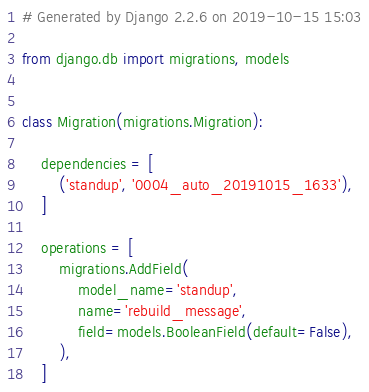Convert code to text. <code><loc_0><loc_0><loc_500><loc_500><_Python_># Generated by Django 2.2.6 on 2019-10-15 15:03

from django.db import migrations, models


class Migration(migrations.Migration):

    dependencies = [
        ('standup', '0004_auto_20191015_1633'),
    ]

    operations = [
        migrations.AddField(
            model_name='standup',
            name='rebuild_message',
            field=models.BooleanField(default=False),
        ),
    ]
</code> 